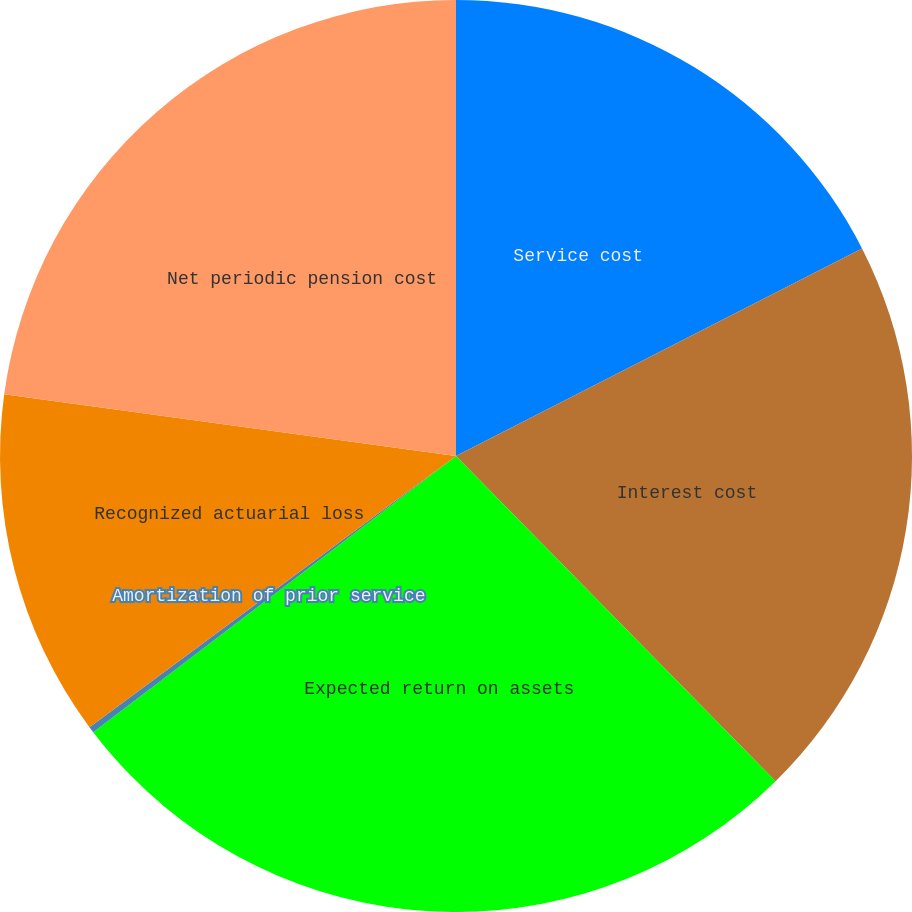<chart> <loc_0><loc_0><loc_500><loc_500><pie_chart><fcel>Service cost<fcel>Interest cost<fcel>Expected return on assets<fcel>Amortization of prior service<fcel>Recognized actuarial loss<fcel>Net periodic pension cost<nl><fcel>17.48%<fcel>20.16%<fcel>27.0%<fcel>0.22%<fcel>12.3%<fcel>22.84%<nl></chart> 